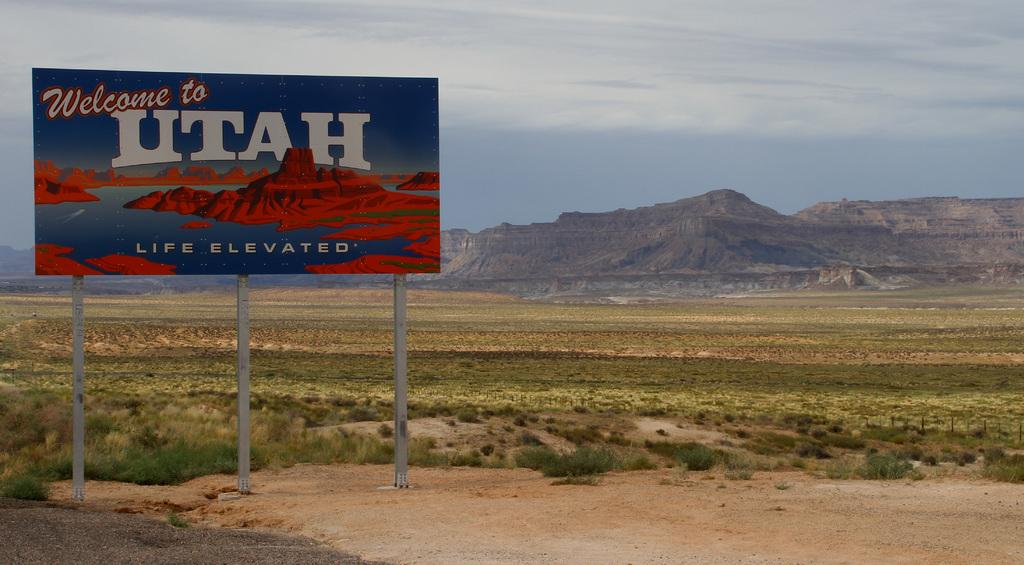<image>
Provide a brief description of the given image. A welcome to Utah sign sits in front of a beautiful mountain side. 